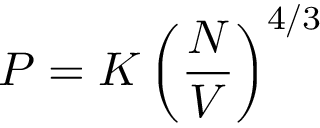Convert formula to latex. <formula><loc_0><loc_0><loc_500><loc_500>P = K \left ( { \frac { N } { V } } \right ) ^ { 4 / 3 }</formula> 